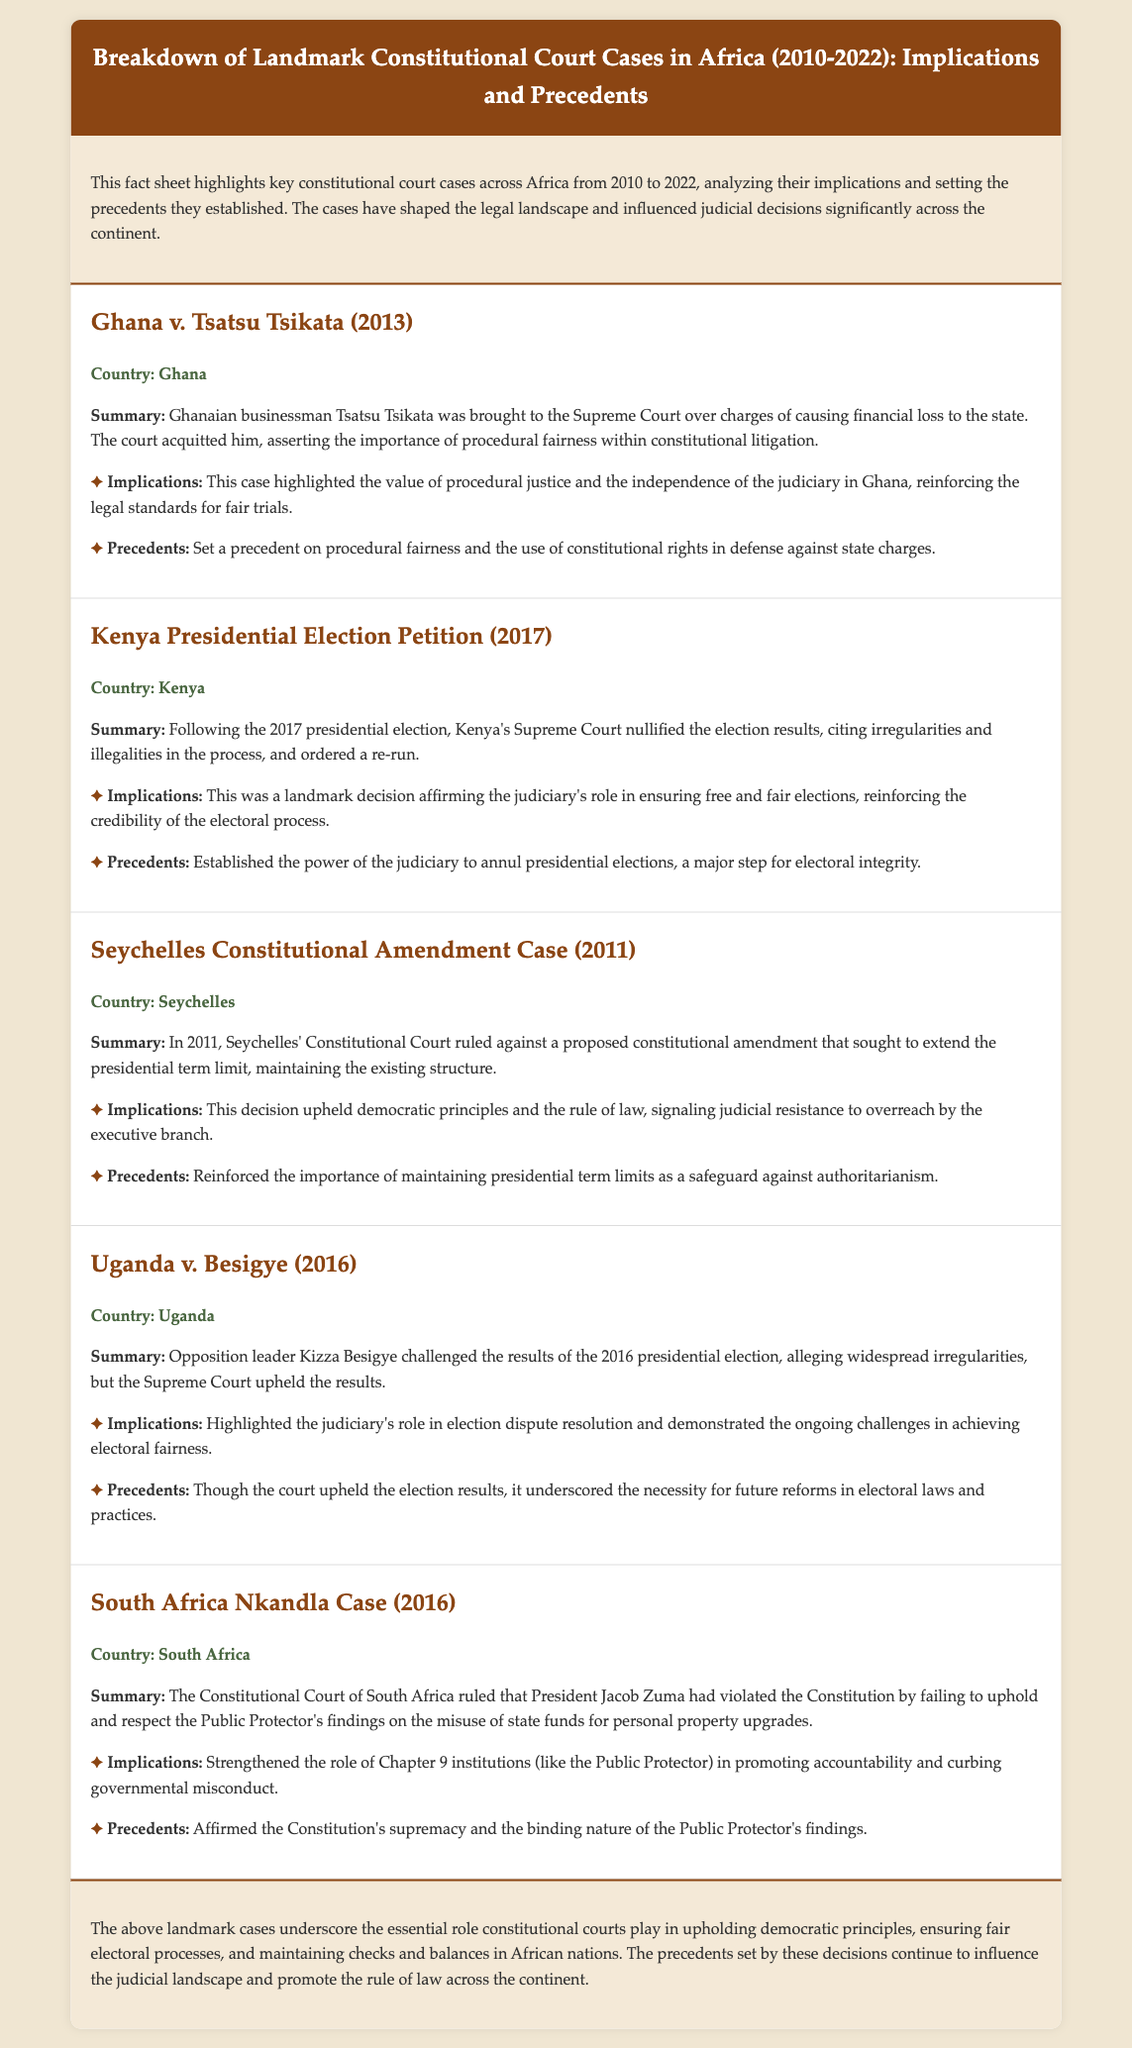What was the outcome of Ghana v. Tsatsu Tsikata? The court acquitted Tsatsu Tsikata, asserting the importance of procedural fairness within constitutional litigation.
Answer: Acquitted What year was the Kenya Presidential Election Petition? The petition occurred in 2017 following the presidential election.
Answer: 2017 Which two cases specifically addressed presidential term limits? The Seychelles Constitutional Amendment Case (2011) maintained existing term limits, while other cases also touched on the presidential election process.
Answer: Seychelles Constitutional Amendment Case What was a key implication of the South Africa Nkandla Case? It strengthened the role of Chapter 9 institutions in promoting accountability and curbing governmental misconduct.
Answer: Strengthened accountability Which country faced challenges in achieving electoral fairness during the 2016 election? Uganda faced such challenges during the election dispute.
Answer: Uganda How did the Kenya Supreme Court contribute to electoral integrity? The court nullified the election results, affirming the judiciary's role in ensuring free and fair elections.
Answer: Nullified election results What did the implications of the Seychelles case emphasize? The decision upheld democratic principles and the rule of law.
Answer: Democratic principles What precedent was set by the South Africa Nkandla Case? The case affirmed the Constitution's supremacy and the binding nature of the Public Protector's findings.
Answer: Constitution's supremacy 